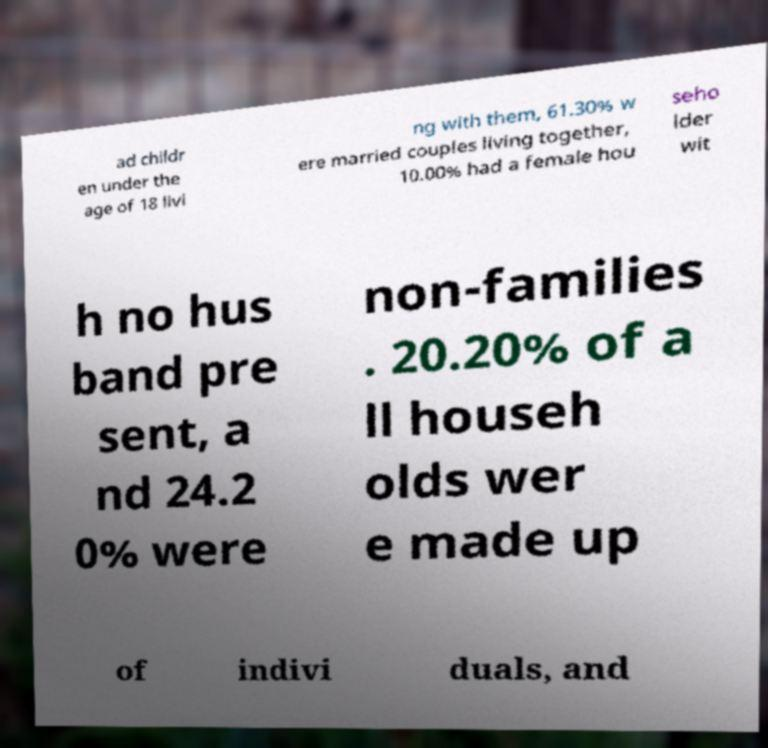Could you assist in decoding the text presented in this image and type it out clearly? ad childr en under the age of 18 livi ng with them, 61.30% w ere married couples living together, 10.00% had a female hou seho lder wit h no hus band pre sent, a nd 24.2 0% were non-families . 20.20% of a ll househ olds wer e made up of indivi duals, and 